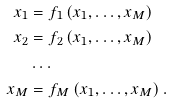<formula> <loc_0><loc_0><loc_500><loc_500>x _ { 1 } & = f _ { 1 } \left ( x _ { 1 } , \dots , x _ { M } \right ) \\ x _ { 2 } & = f _ { 2 } \left ( x _ { 1 } , \dots , x _ { M } \right ) \\ & \dots \\ x _ { M } & = f _ { M } \left ( x _ { 1 } , \dots , x _ { M } \right ) .</formula> 